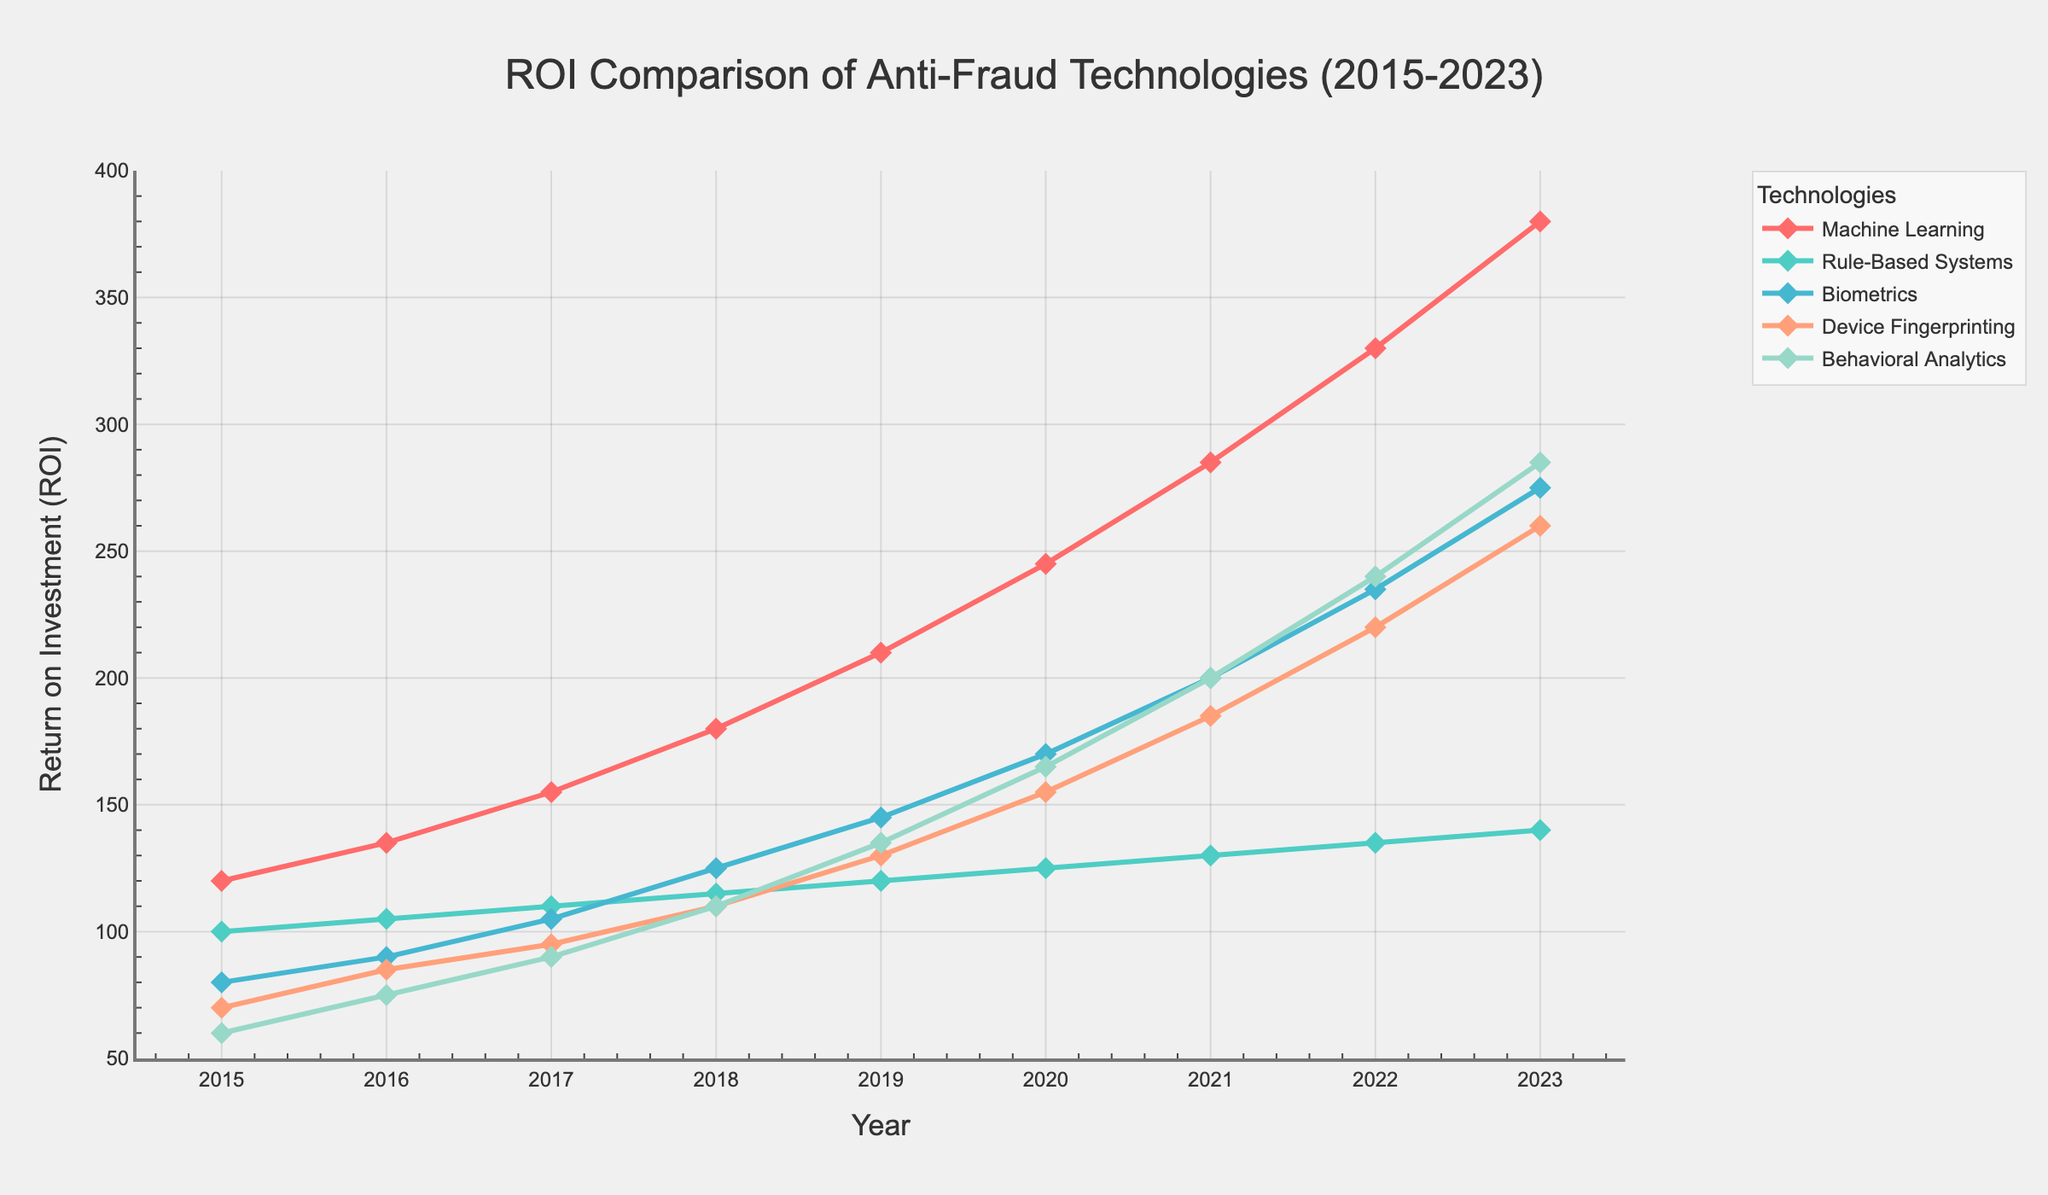What's the trend of ROI for Machine Learning from 2015 to 2023? The plot shows a continuous increase in the ROI for Machine Learning from 2015 to 2023. Starting from 120 in 2015 and rising to 380 in 2023, it has the highest upward trend among all technologies.
Answer: Continuous increase Between Device Fingerprinting and Behavioral Analytics, which technology had a higher ROI in 2018? The plot indicates that Device Fingerprinting had an ROI of 110 in 2018, while Behavioral Analytics had an ROI of 110 in the same year, making them equal.
Answer: Equal How does the ROI of Biometrics in 2023 compare to that in 2015? In 2015, the ROI for Biometrics was 80, and it increased to 275 in 2023. To compare: 275 - 80 = 195. Therefore, the ROI increased by 195 units over this period.
Answer: Increased by 195 What's the difference in ROI between Rule-Based Systems and Machine Learning in 2020? In 2020, the ROI for Rule-Based Systems was 125 and for Machine Learning was 245. The difference is 245 - 125 = 120.
Answer: 120 Which technology had the steepest increase in ROI from 2019 to 2020? The plot shows that Machine Learning increased from 210 to 245 (35 units), Rule-Based Systems from 120 to 125 (5 units), Biometrics from 145 to 170 (25 units), Device Fingerprinting from 130 to 155 (25 units), and Behavioral Analytics from 135 to 165 (30 units). The steepest increase was in Behavioral Analytics.
Answer: Behavioral Analytics What's the average ROI of the five technologies in 2022? The ROIs for 2022 are: Machine Learning (330), Rule-Based Systems (135), Biometrics (235), Device Fingerprinting (220), Behavioral Analytics (240). The average is (330 + 135 + 235 + 220 + 240) / 5 = 1160 / 5 = 232.
Answer: 232 In which year did Behavioral Analytics cross the 200 ROI mark, and what was the exact value that year? The plot shows that Behavioral Analytics crossed the 200 mark in 2021, with an exact ROI of 200, and further increased in 2022 to 240.
Answer: 2021, 200 Between 2017 and 2019, which technology had the largest incremental increase in ROI? By calculating the differences: Machine Learning (210 - 155 = 55), Rule-Based Systems (120 - 110 = 10), Biometrics (145 - 105 = 40), Device Fingerprinting (130 - 95 = 35), Behavioral Analytics (135 - 90 = 45). The largest increase is in Machine Learning with 55 units increase.
Answer: Machine Learning What's the color representing Machine Learning on the plot? The plot uses different colors to differentiate the technologies, and Machine Learning is represented by red.
Answer: Red 